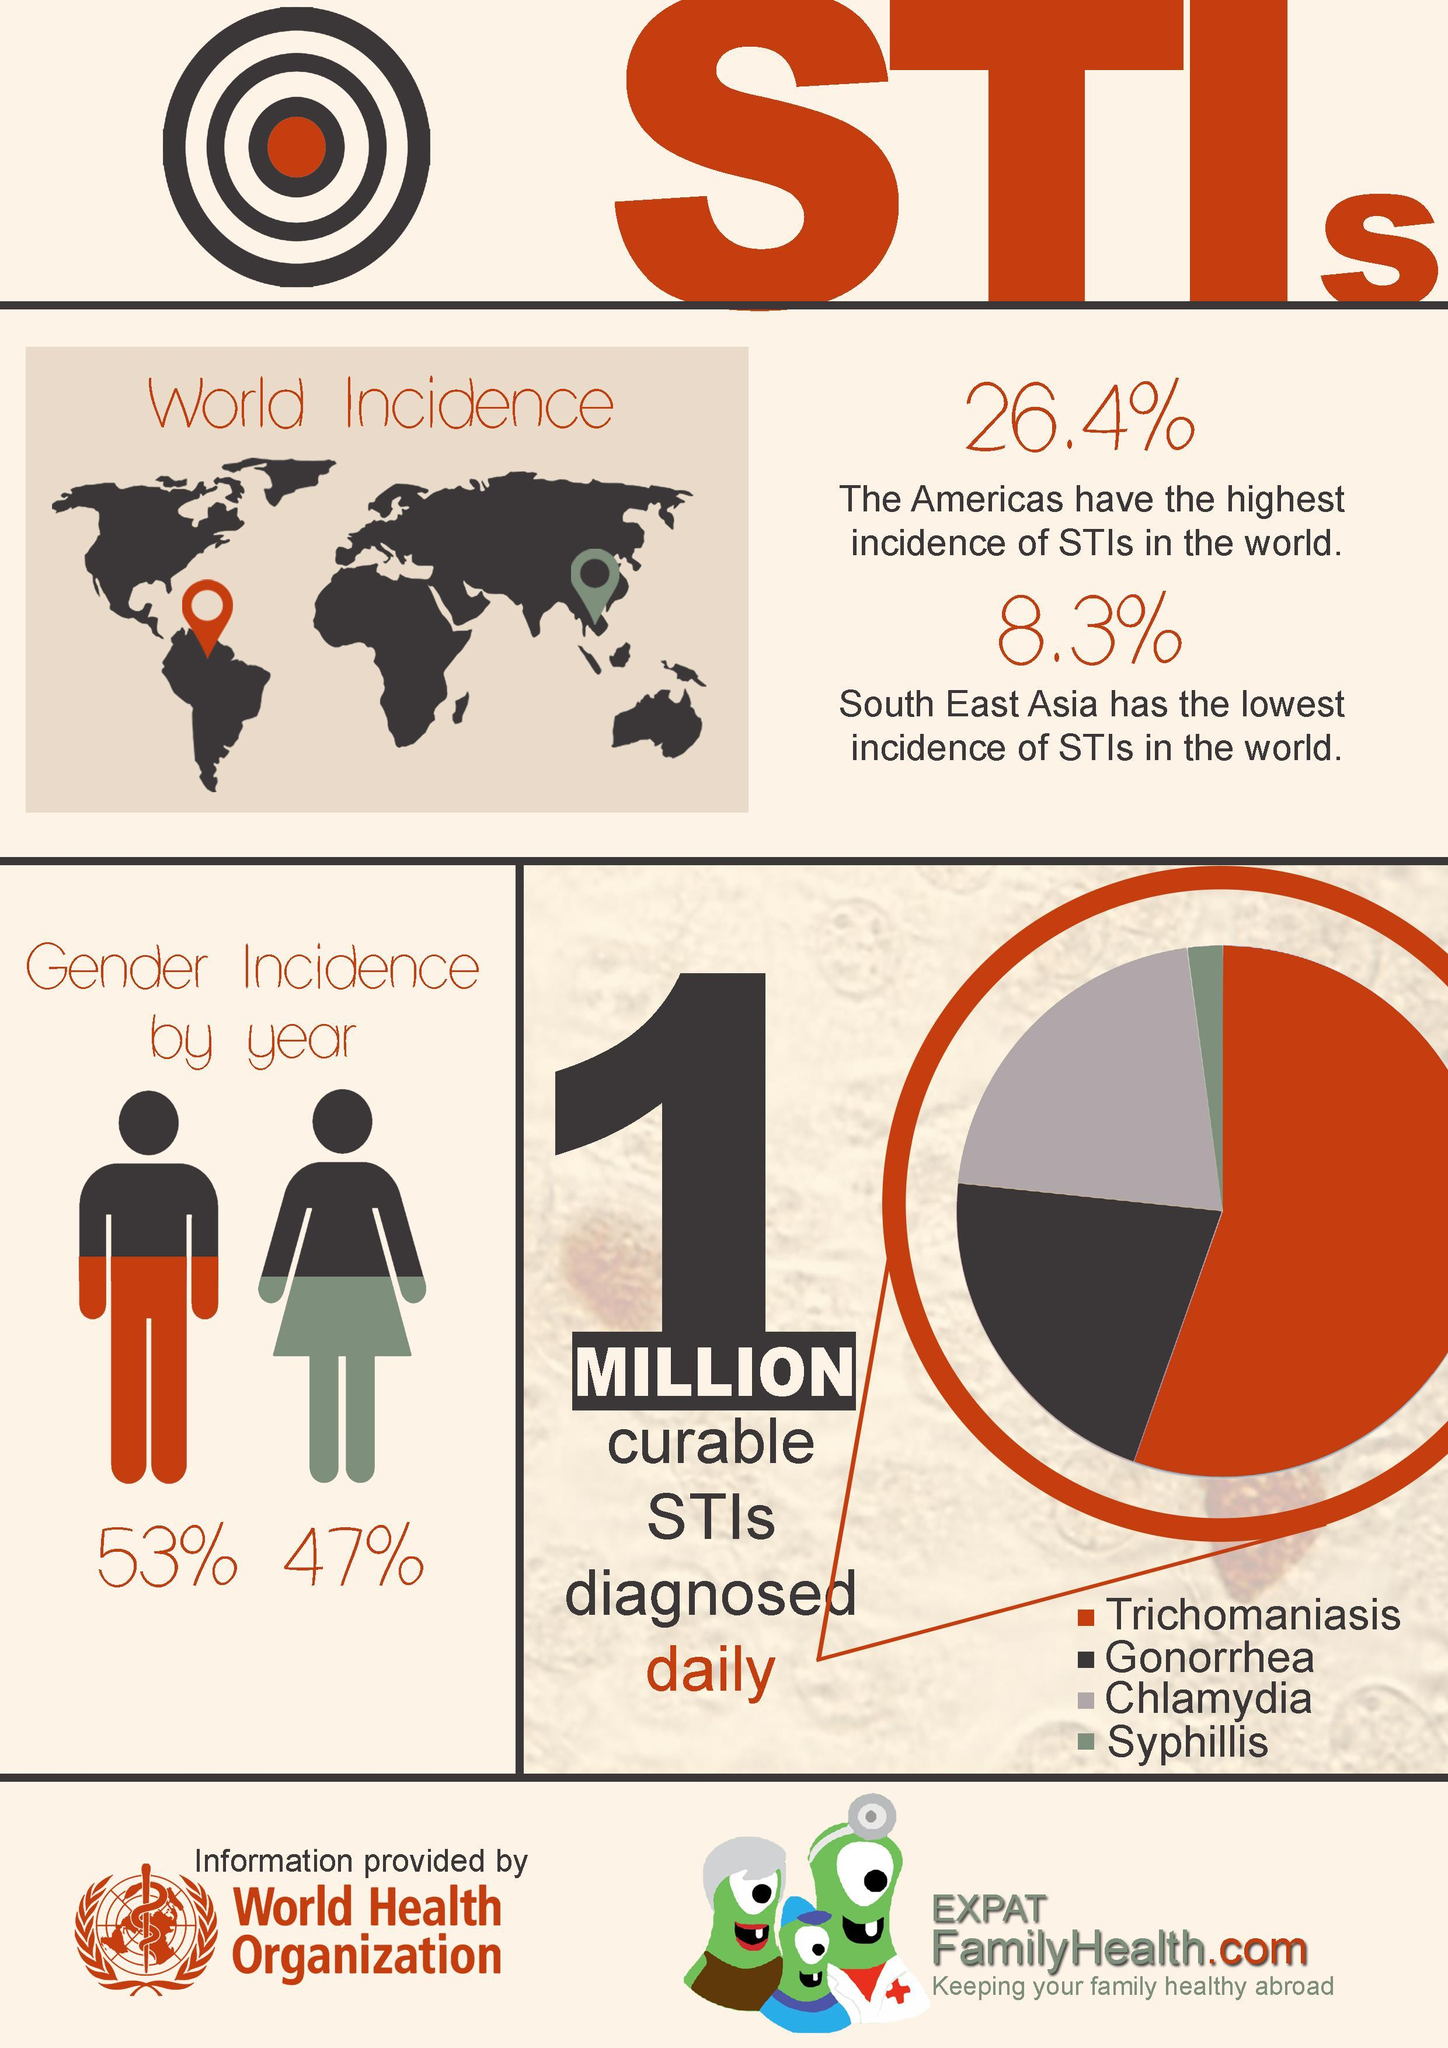Which STI is second highest in incidence?
Answer the question with a short phrase. Gonorrhea What is the difference between the rate of incidence of STIs in the Americas and South East Asia? 18.1% By what percent is the rate of STIs in women lower than men? 6% Which are the top three STIs as per the graph? Trichomaniasis, Gonorrhea, Chlamydia Which gender has more incidences of STIs- men or women? men 